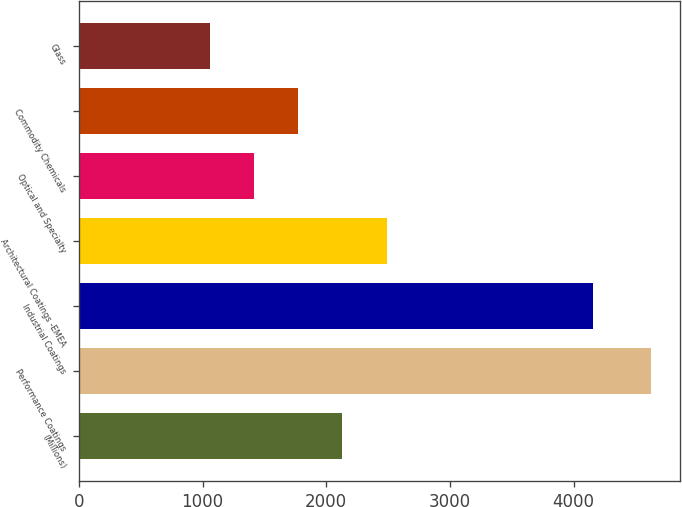Convert chart to OTSL. <chart><loc_0><loc_0><loc_500><loc_500><bar_chart><fcel>(Millions)<fcel>Performance Coatings<fcel>Industrial Coatings<fcel>Architectural Coatings -EMEA<fcel>Optical and Specialty<fcel>Commodity Chemicals<fcel>Glass<nl><fcel>2130.5<fcel>4626<fcel>4158<fcel>2487<fcel>1417.5<fcel>1774<fcel>1061<nl></chart> 